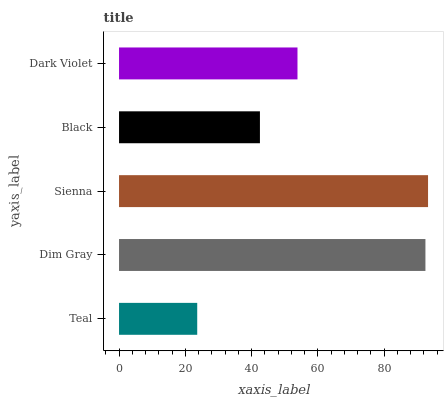Is Teal the minimum?
Answer yes or no. Yes. Is Sienna the maximum?
Answer yes or no. Yes. Is Dim Gray the minimum?
Answer yes or no. No. Is Dim Gray the maximum?
Answer yes or no. No. Is Dim Gray greater than Teal?
Answer yes or no. Yes. Is Teal less than Dim Gray?
Answer yes or no. Yes. Is Teal greater than Dim Gray?
Answer yes or no. No. Is Dim Gray less than Teal?
Answer yes or no. No. Is Dark Violet the high median?
Answer yes or no. Yes. Is Dark Violet the low median?
Answer yes or no. Yes. Is Dim Gray the high median?
Answer yes or no. No. Is Sienna the low median?
Answer yes or no. No. 